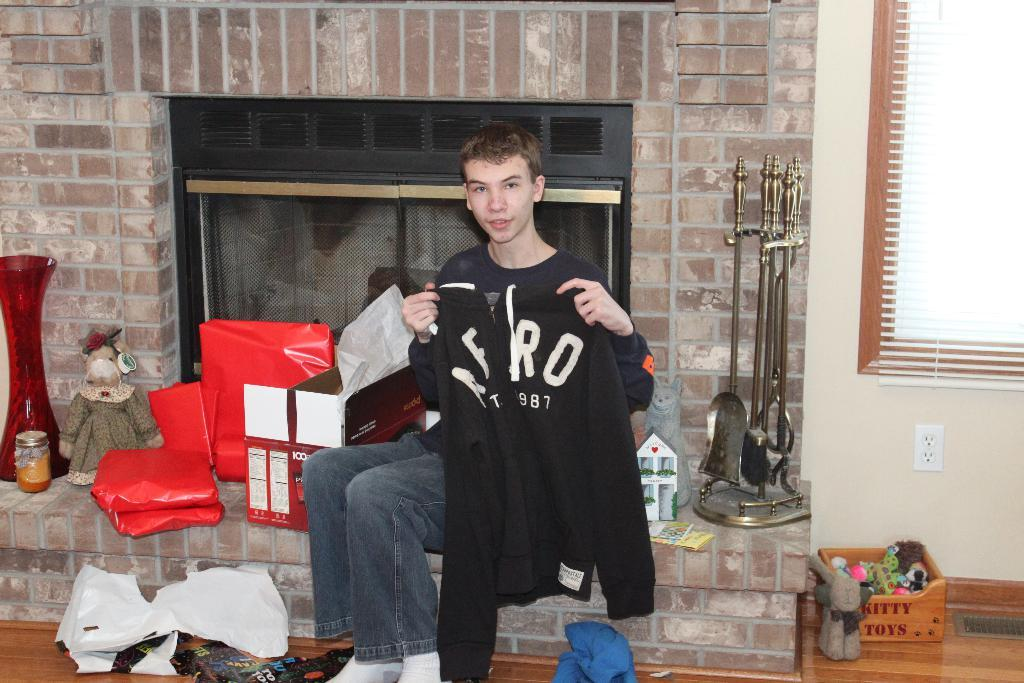<image>
Create a compact narrative representing the image presented. A younger man sitting on a fireplace ledge holding an Aero Postle sweater. 